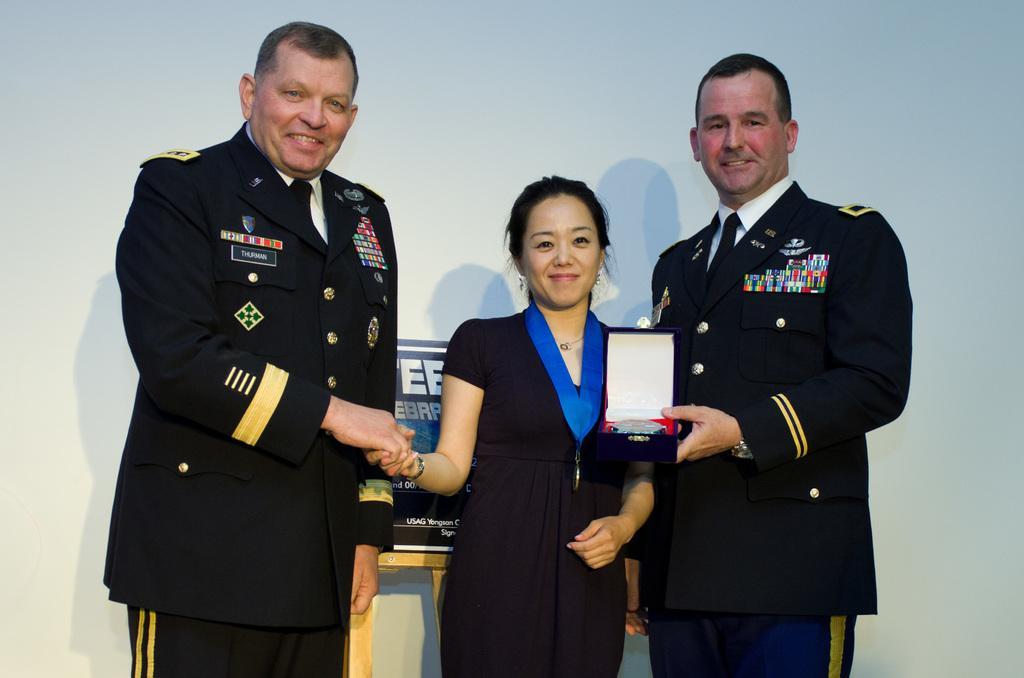How would you summarize this image in a sentence or two? This picture seems to be clicked inside. On the left there is a person wearing uniform, smiling and standing. In the center there is a woman wearing black color dress, smiling, standing and both of them are shaking their hands. On the right there is another person wearing uniform, holding an object and standing. In the background we can see the wall and an object on which we can see the text is printed. 